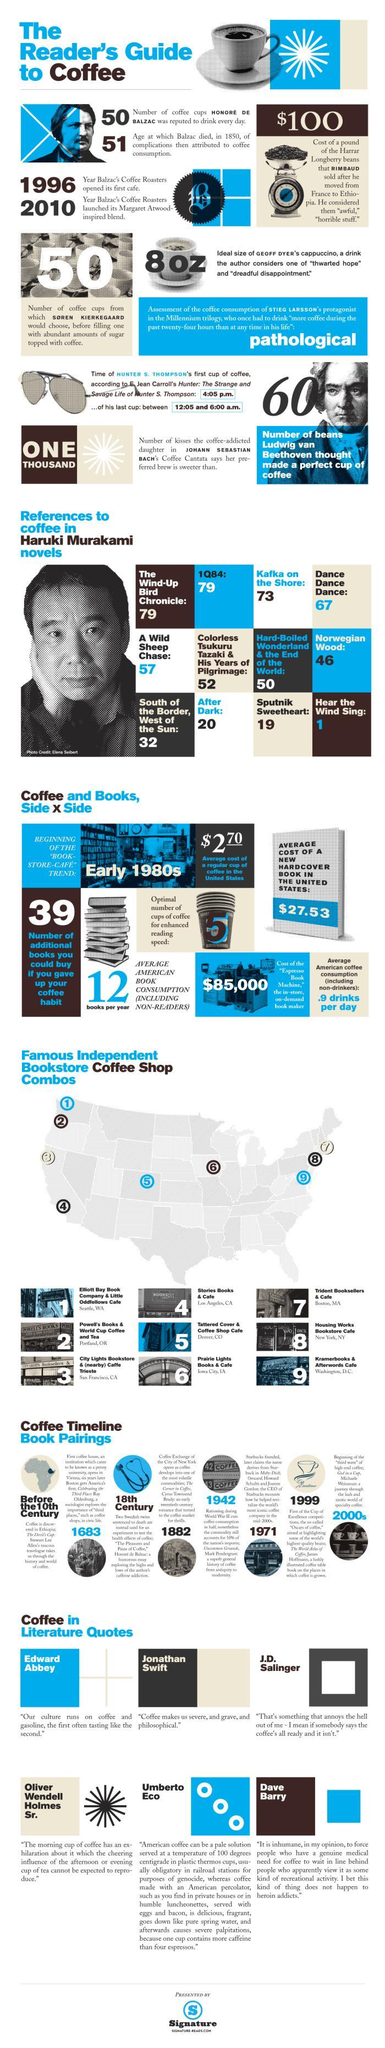How many times the word Coffee written in the novel "A Wild Sheep Chase"?
Answer the question with a short phrase. 57 n which work there are 46 pieces of evidence to the famous drink "Coffee"? Norwegian Wood In which work there are 67 pieces of evidence to the famous drink "Coffee"? Dance Dance Dance What is the name of the Bookstore Coffee Shop in Los Angeles? Stories Books & Cafe How many times the word Coffee written in the novel "Kafka On The Shore"? 73 What is the number given to the Bookstore Coffee Shop shown towards the extreme east on the map? 7 In which popular work only a single reference to the famous drink "Coffee" is present? Hear The Wind Sing What is the number given to the Bookstore Coffee Shop shown towards the extreme west on the map? 3 In which work there are 19 pieces of evidence to the famous drink "Coffee"? Sputnik Sweetheart Who is the famous person who mentioned "Coffee" in most of his works? Haruki Murakami 